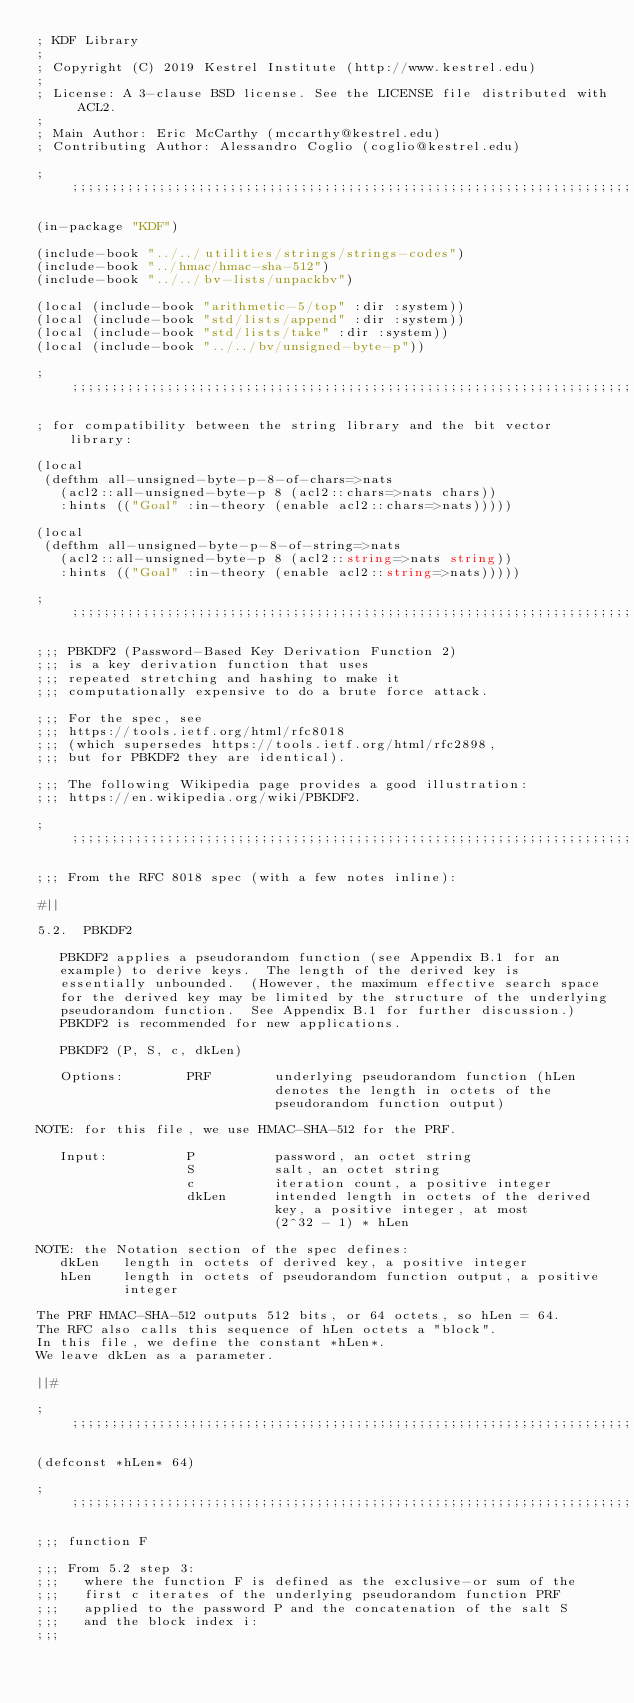Convert code to text. <code><loc_0><loc_0><loc_500><loc_500><_Lisp_>; KDF Library
;
; Copyright (C) 2019 Kestrel Institute (http://www.kestrel.edu)
;
; License: A 3-clause BSD license. See the LICENSE file distributed with ACL2.
;
; Main Author: Eric McCarthy (mccarthy@kestrel.edu)
; Contributing Author: Alessandro Coglio (coglio@kestrel.edu)

;;;;;;;;;;;;;;;;;;;;;;;;;;;;;;;;;;;;;;;;;;;;;;;;;;;;;;;;;;;;;;;;;;;;;;;;;;;;;;;;

(in-package "KDF")

(include-book "../../utilities/strings/strings-codes")
(include-book "../hmac/hmac-sha-512")
(include-book "../../bv-lists/unpackbv")

(local (include-book "arithmetic-5/top" :dir :system))
(local (include-book "std/lists/append" :dir :system))
(local (include-book "std/lists/take" :dir :system))
(local (include-book "../../bv/unsigned-byte-p"))

;;;;;;;;;;;;;;;;;;;;;;;;;;;;;;;;;;;;;;;;;;;;;;;;;;;;;;;;;;;;;;;;;;;;;;;;;;;;;;;;

; for compatibility between the string library and the bit vector library:

(local
 (defthm all-unsigned-byte-p-8-of-chars=>nats
   (acl2::all-unsigned-byte-p 8 (acl2::chars=>nats chars))
   :hints (("Goal" :in-theory (enable acl2::chars=>nats)))))

(local
 (defthm all-unsigned-byte-p-8-of-string=>nats
   (acl2::all-unsigned-byte-p 8 (acl2::string=>nats string))
   :hints (("Goal" :in-theory (enable acl2::string=>nats)))))

;;;;;;;;;;;;;;;;;;;;;;;;;;;;;;;;;;;;;;;;;;;;;;;;;;;;;;;;;;;;;;;;;;;;;;;;;;;;;;;;

;;; PBKDF2 (Password-Based Key Derivation Function 2)
;;; is a key derivation function that uses
;;; repeated stretching and hashing to make it
;;; computationally expensive to do a brute force attack.

;;; For the spec, see
;;; https://tools.ietf.org/html/rfc8018
;;; (which supersedes https://tools.ietf.org/html/rfc2898,
;;; but for PBKDF2 they are identical).

;;; The following Wikipedia page provides a good illustration:
;;; https://en.wikipedia.org/wiki/PBKDF2.

;;;;;;;;;;;;;;;;;;;;;;;;;;;;;;;;;;;;;;;;;;;;;;;;;;;;;;;;;;;;;;;;;;;;;;;;;;;;;;;;

;;; From the RFC 8018 spec (with a few notes inline):

#||

5.2.  PBKDF2

   PBKDF2 applies a pseudorandom function (see Appendix B.1 for an
   example) to derive keys.  The length of the derived key is
   essentially unbounded.  (However, the maximum effective search space
   for the derived key may be limited by the structure of the underlying
   pseudorandom function.  See Appendix B.1 for further discussion.)
   PBKDF2 is recommended for new applications.

   PBKDF2 (P, S, c, dkLen)

   Options:        PRF        underlying pseudorandom function (hLen
                              denotes the length in octets of the
                              pseudorandom function output)

NOTE: for this file, we use HMAC-SHA-512 for the PRF.

   Input:          P          password, an octet string
                   S          salt, an octet string
                   c          iteration count, a positive integer
                   dkLen      intended length in octets of the derived
                              key, a positive integer, at most
                              (2^32 - 1) * hLen

NOTE: the Notation section of the spec defines:
   dkLen   length in octets of derived key, a positive integer
   hLen    length in octets of pseudorandom function output, a positive
           integer

The PRF HMAC-SHA-512 outputs 512 bits, or 64 octets, so hLen = 64.
The RFC also calls this sequence of hLen octets a "block".
In this file, we define the constant *hLen*.
We leave dkLen as a parameter.

||#

;;;;;;;;;;;;;;;;;;;;;;;;;;;;;;;;;;;;;;;;;;;;;;;;;;;;;;;;;;;;;;;;;;;;;;;;;;;;;;;;

(defconst *hLen* 64)

;;;;;;;;;;;;;;;;;;;;;;;;;;;;;;;;;;;;;;;;;;;;;;;;;;;;;;;;;;;;;;;;;;;;;;;;;;;;;;;;

;;; function F

;;; From 5.2 step 3:
;;;   where the function F is defined as the exclusive-or sum of the
;;;   first c iterates of the underlying pseudorandom function PRF
;;;   applied to the password P and the concatenation of the salt S
;;;   and the block index i:
;;;</code> 